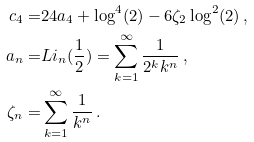<formula> <loc_0><loc_0><loc_500><loc_500>c _ { 4 } = & 2 4 a _ { 4 } + \log ^ { 4 } ( 2 ) - 6 \zeta _ { 2 } \log ^ { 2 } ( 2 ) \, , \\ a _ { n } = & L i _ { n } ( \frac { 1 } { 2 } ) = \sum _ { k = 1 } ^ { \infty } \frac { 1 } { 2 ^ { k } k ^ { n } } \, , \\ \zeta _ { n } = & \sum _ { k = 1 } ^ { \infty } \frac { 1 } { k ^ { n } } \, .</formula> 